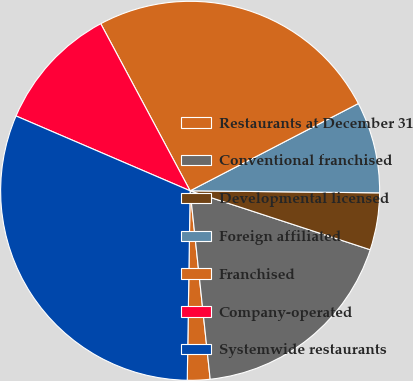Convert chart. <chart><loc_0><loc_0><loc_500><loc_500><pie_chart><fcel>Restaurants at December 31<fcel>Conventional franchised<fcel>Developmental licensed<fcel>Foreign affiliated<fcel>Franchised<fcel>Company-operated<fcel>Systemwide restaurants<nl><fcel>1.93%<fcel>18.28%<fcel>4.86%<fcel>7.79%<fcel>25.2%<fcel>10.72%<fcel>31.22%<nl></chart> 